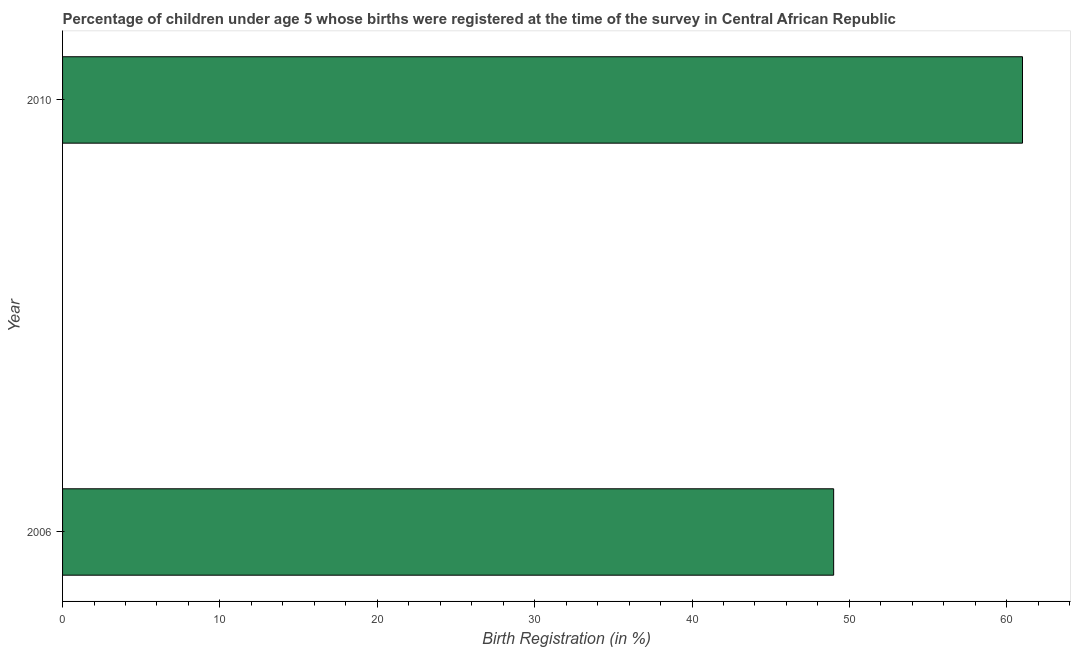Does the graph contain grids?
Provide a succinct answer. No. What is the title of the graph?
Keep it short and to the point. Percentage of children under age 5 whose births were registered at the time of the survey in Central African Republic. What is the label or title of the X-axis?
Offer a terse response. Birth Registration (in %). Across all years, what is the minimum birth registration?
Make the answer very short. 49. In which year was the birth registration maximum?
Your answer should be very brief. 2010. What is the sum of the birth registration?
Ensure brevity in your answer.  110. What is the difference between the birth registration in 2006 and 2010?
Provide a succinct answer. -12. What is the median birth registration?
Offer a terse response. 55. What is the ratio of the birth registration in 2006 to that in 2010?
Make the answer very short. 0.8. How many bars are there?
Your response must be concise. 2. Are all the bars in the graph horizontal?
Make the answer very short. Yes. What is the Birth Registration (in %) in 2010?
Keep it short and to the point. 61. What is the ratio of the Birth Registration (in %) in 2006 to that in 2010?
Offer a very short reply. 0.8. 